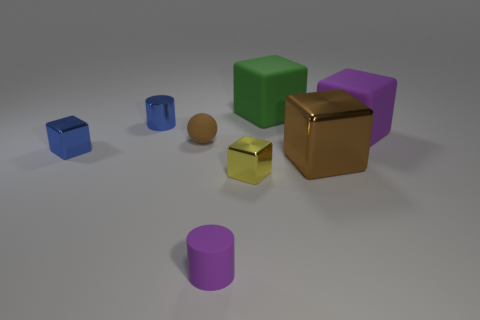What size is the green cube?
Keep it short and to the point. Large. Is the number of small blue cylinders behind the large brown thing the same as the number of gray metallic cubes?
Keep it short and to the point. No. What is the color of the rubber object that is both right of the small yellow cube and in front of the green matte object?
Offer a very short reply. Purple. There is a block to the left of the blue metal object behind the large matte thing to the right of the green object; what is its size?
Offer a terse response. Small. How many objects are big matte things that are in front of the green rubber block or matte blocks to the right of the large brown metal thing?
Your answer should be very brief. 1. What is the shape of the tiny purple rubber thing?
Offer a terse response. Cylinder. How many other things are the same material as the purple cube?
Offer a terse response. 3. What size is the brown object that is the same shape as the green matte thing?
Give a very brief answer. Large. What material is the cube to the left of the small blue object that is behind the rubber object that is left of the purple cylinder made of?
Ensure brevity in your answer.  Metal. Are any green metal balls visible?
Provide a short and direct response. No. 